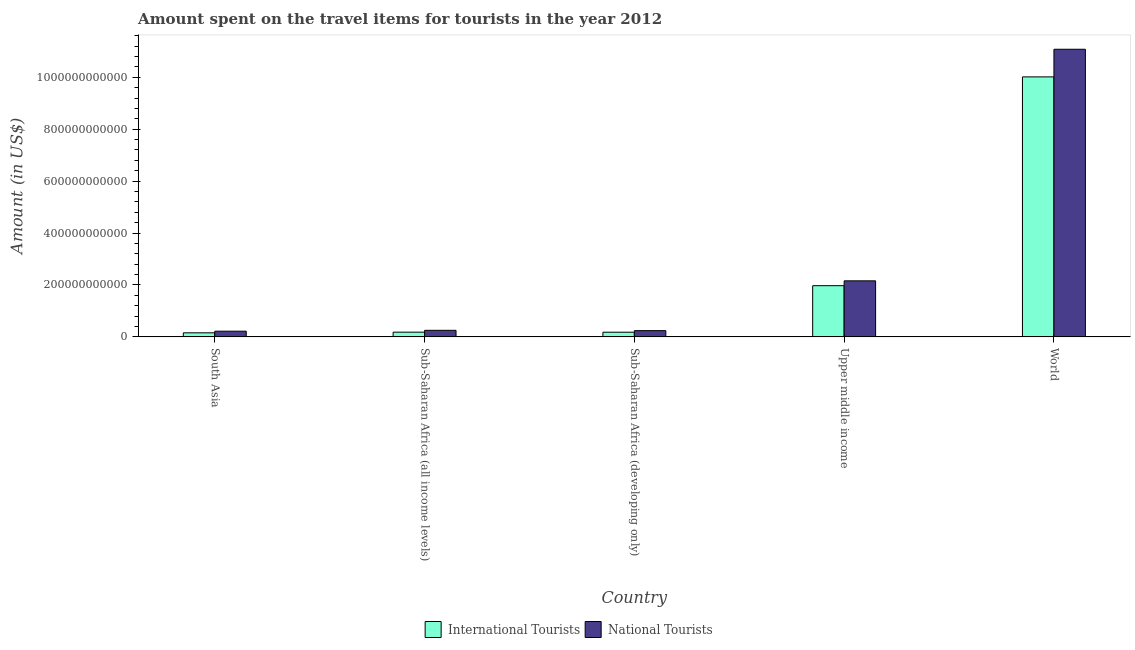How many different coloured bars are there?
Provide a succinct answer. 2. Are the number of bars per tick equal to the number of legend labels?
Keep it short and to the point. Yes. What is the label of the 3rd group of bars from the left?
Your answer should be very brief. Sub-Saharan Africa (developing only). What is the amount spent on travel items of national tourists in Sub-Saharan Africa (developing only)?
Offer a very short reply. 2.40e+1. Across all countries, what is the maximum amount spent on travel items of international tourists?
Your answer should be very brief. 1.00e+12. Across all countries, what is the minimum amount spent on travel items of national tourists?
Your answer should be very brief. 2.19e+1. In which country was the amount spent on travel items of international tourists maximum?
Offer a terse response. World. In which country was the amount spent on travel items of national tourists minimum?
Your response must be concise. South Asia. What is the total amount spent on travel items of national tourists in the graph?
Your answer should be compact. 1.40e+12. What is the difference between the amount spent on travel items of national tourists in South Asia and that in Sub-Saharan Africa (developing only)?
Your response must be concise. -2.14e+09. What is the difference between the amount spent on travel items of international tourists in Sub-Saharan Africa (developing only) and the amount spent on travel items of national tourists in World?
Make the answer very short. -1.09e+12. What is the average amount spent on travel items of national tourists per country?
Provide a short and direct response. 2.79e+11. What is the difference between the amount spent on travel items of national tourists and amount spent on travel items of international tourists in Sub-Saharan Africa (all income levels)?
Your response must be concise. 7.15e+09. What is the ratio of the amount spent on travel items of international tourists in Sub-Saharan Africa (all income levels) to that in Sub-Saharan Africa (developing only)?
Provide a succinct answer. 1.01. Is the amount spent on travel items of national tourists in South Asia less than that in Sub-Saharan Africa (developing only)?
Offer a terse response. Yes. Is the difference between the amount spent on travel items of national tourists in Sub-Saharan Africa (all income levels) and World greater than the difference between the amount spent on travel items of international tourists in Sub-Saharan Africa (all income levels) and World?
Make the answer very short. No. What is the difference between the highest and the second highest amount spent on travel items of international tourists?
Provide a succinct answer. 8.04e+11. What is the difference between the highest and the lowest amount spent on travel items of national tourists?
Offer a terse response. 1.09e+12. Is the sum of the amount spent on travel items of international tourists in Sub-Saharan Africa (developing only) and Upper middle income greater than the maximum amount spent on travel items of national tourists across all countries?
Make the answer very short. No. What does the 1st bar from the left in Sub-Saharan Africa (developing only) represents?
Keep it short and to the point. International Tourists. What does the 2nd bar from the right in World represents?
Provide a succinct answer. International Tourists. What is the difference between two consecutive major ticks on the Y-axis?
Keep it short and to the point. 2.00e+11. Are the values on the major ticks of Y-axis written in scientific E-notation?
Give a very brief answer. No. How many legend labels are there?
Offer a terse response. 2. How are the legend labels stacked?
Give a very brief answer. Horizontal. What is the title of the graph?
Your answer should be compact. Amount spent on the travel items for tourists in the year 2012. Does "Nitrous oxide emissions" appear as one of the legend labels in the graph?
Give a very brief answer. No. What is the Amount (in US$) in International Tourists in South Asia?
Keep it short and to the point. 1.56e+1. What is the Amount (in US$) of National Tourists in South Asia?
Offer a terse response. 2.19e+1. What is the Amount (in US$) in International Tourists in Sub-Saharan Africa (all income levels)?
Your response must be concise. 1.81e+1. What is the Amount (in US$) in National Tourists in Sub-Saharan Africa (all income levels)?
Your answer should be compact. 2.53e+1. What is the Amount (in US$) in International Tourists in Sub-Saharan Africa (developing only)?
Provide a short and direct response. 1.79e+1. What is the Amount (in US$) of National Tourists in Sub-Saharan Africa (developing only)?
Your answer should be compact. 2.40e+1. What is the Amount (in US$) of International Tourists in Upper middle income?
Your response must be concise. 1.97e+11. What is the Amount (in US$) in National Tourists in Upper middle income?
Your answer should be very brief. 2.16e+11. What is the Amount (in US$) in International Tourists in World?
Give a very brief answer. 1.00e+12. What is the Amount (in US$) of National Tourists in World?
Your response must be concise. 1.11e+12. Across all countries, what is the maximum Amount (in US$) of International Tourists?
Offer a terse response. 1.00e+12. Across all countries, what is the maximum Amount (in US$) of National Tourists?
Your answer should be very brief. 1.11e+12. Across all countries, what is the minimum Amount (in US$) in International Tourists?
Keep it short and to the point. 1.56e+1. Across all countries, what is the minimum Amount (in US$) in National Tourists?
Your response must be concise. 2.19e+1. What is the total Amount (in US$) of International Tourists in the graph?
Your response must be concise. 1.25e+12. What is the total Amount (in US$) in National Tourists in the graph?
Ensure brevity in your answer.  1.40e+12. What is the difference between the Amount (in US$) in International Tourists in South Asia and that in Sub-Saharan Africa (all income levels)?
Offer a terse response. -2.49e+09. What is the difference between the Amount (in US$) in National Tourists in South Asia and that in Sub-Saharan Africa (all income levels)?
Offer a very short reply. -3.35e+09. What is the difference between the Amount (in US$) of International Tourists in South Asia and that in Sub-Saharan Africa (developing only)?
Keep it short and to the point. -2.32e+09. What is the difference between the Amount (in US$) in National Tourists in South Asia and that in Sub-Saharan Africa (developing only)?
Your answer should be very brief. -2.14e+09. What is the difference between the Amount (in US$) in International Tourists in South Asia and that in Upper middle income?
Offer a very short reply. -1.82e+11. What is the difference between the Amount (in US$) in National Tourists in South Asia and that in Upper middle income?
Your response must be concise. -1.94e+11. What is the difference between the Amount (in US$) in International Tourists in South Asia and that in World?
Offer a very short reply. -9.86e+11. What is the difference between the Amount (in US$) in National Tourists in South Asia and that in World?
Ensure brevity in your answer.  -1.09e+12. What is the difference between the Amount (in US$) in International Tourists in Sub-Saharan Africa (all income levels) and that in Sub-Saharan Africa (developing only)?
Ensure brevity in your answer.  1.68e+08. What is the difference between the Amount (in US$) of National Tourists in Sub-Saharan Africa (all income levels) and that in Sub-Saharan Africa (developing only)?
Provide a short and direct response. 1.21e+09. What is the difference between the Amount (in US$) in International Tourists in Sub-Saharan Africa (all income levels) and that in Upper middle income?
Give a very brief answer. -1.79e+11. What is the difference between the Amount (in US$) in National Tourists in Sub-Saharan Africa (all income levels) and that in Upper middle income?
Make the answer very short. -1.91e+11. What is the difference between the Amount (in US$) of International Tourists in Sub-Saharan Africa (all income levels) and that in World?
Provide a succinct answer. -9.84e+11. What is the difference between the Amount (in US$) of National Tourists in Sub-Saharan Africa (all income levels) and that in World?
Offer a terse response. -1.08e+12. What is the difference between the Amount (in US$) of International Tourists in Sub-Saharan Africa (developing only) and that in Upper middle income?
Offer a terse response. -1.79e+11. What is the difference between the Amount (in US$) of National Tourists in Sub-Saharan Africa (developing only) and that in Upper middle income?
Give a very brief answer. -1.92e+11. What is the difference between the Amount (in US$) in International Tourists in Sub-Saharan Africa (developing only) and that in World?
Ensure brevity in your answer.  -9.84e+11. What is the difference between the Amount (in US$) in National Tourists in Sub-Saharan Africa (developing only) and that in World?
Your response must be concise. -1.08e+12. What is the difference between the Amount (in US$) of International Tourists in Upper middle income and that in World?
Provide a short and direct response. -8.04e+11. What is the difference between the Amount (in US$) in National Tourists in Upper middle income and that in World?
Your response must be concise. -8.92e+11. What is the difference between the Amount (in US$) in International Tourists in South Asia and the Amount (in US$) in National Tourists in Sub-Saharan Africa (all income levels)?
Offer a terse response. -9.64e+09. What is the difference between the Amount (in US$) of International Tourists in South Asia and the Amount (in US$) of National Tourists in Sub-Saharan Africa (developing only)?
Make the answer very short. -8.43e+09. What is the difference between the Amount (in US$) in International Tourists in South Asia and the Amount (in US$) in National Tourists in Upper middle income?
Ensure brevity in your answer.  -2.00e+11. What is the difference between the Amount (in US$) of International Tourists in South Asia and the Amount (in US$) of National Tourists in World?
Your response must be concise. -1.09e+12. What is the difference between the Amount (in US$) of International Tourists in Sub-Saharan Africa (all income levels) and the Amount (in US$) of National Tourists in Sub-Saharan Africa (developing only)?
Your answer should be very brief. -5.93e+09. What is the difference between the Amount (in US$) in International Tourists in Sub-Saharan Africa (all income levels) and the Amount (in US$) in National Tourists in Upper middle income?
Ensure brevity in your answer.  -1.98e+11. What is the difference between the Amount (in US$) of International Tourists in Sub-Saharan Africa (all income levels) and the Amount (in US$) of National Tourists in World?
Your answer should be compact. -1.09e+12. What is the difference between the Amount (in US$) of International Tourists in Sub-Saharan Africa (developing only) and the Amount (in US$) of National Tourists in Upper middle income?
Your answer should be very brief. -1.98e+11. What is the difference between the Amount (in US$) of International Tourists in Sub-Saharan Africa (developing only) and the Amount (in US$) of National Tourists in World?
Make the answer very short. -1.09e+12. What is the difference between the Amount (in US$) in International Tourists in Upper middle income and the Amount (in US$) in National Tourists in World?
Give a very brief answer. -9.11e+11. What is the average Amount (in US$) in International Tourists per country?
Give a very brief answer. 2.50e+11. What is the average Amount (in US$) of National Tourists per country?
Your response must be concise. 2.79e+11. What is the difference between the Amount (in US$) in International Tourists and Amount (in US$) in National Tourists in South Asia?
Provide a short and direct response. -6.29e+09. What is the difference between the Amount (in US$) of International Tourists and Amount (in US$) of National Tourists in Sub-Saharan Africa (all income levels)?
Keep it short and to the point. -7.15e+09. What is the difference between the Amount (in US$) in International Tourists and Amount (in US$) in National Tourists in Sub-Saharan Africa (developing only)?
Give a very brief answer. -6.10e+09. What is the difference between the Amount (in US$) in International Tourists and Amount (in US$) in National Tourists in Upper middle income?
Give a very brief answer. -1.86e+1. What is the difference between the Amount (in US$) of International Tourists and Amount (in US$) of National Tourists in World?
Make the answer very short. -1.06e+11. What is the ratio of the Amount (in US$) of International Tourists in South Asia to that in Sub-Saharan Africa (all income levels)?
Provide a succinct answer. 0.86. What is the ratio of the Amount (in US$) of National Tourists in South Asia to that in Sub-Saharan Africa (all income levels)?
Offer a terse response. 0.87. What is the ratio of the Amount (in US$) of International Tourists in South Asia to that in Sub-Saharan Africa (developing only)?
Provide a succinct answer. 0.87. What is the ratio of the Amount (in US$) in National Tourists in South Asia to that in Sub-Saharan Africa (developing only)?
Offer a terse response. 0.91. What is the ratio of the Amount (in US$) in International Tourists in South Asia to that in Upper middle income?
Offer a terse response. 0.08. What is the ratio of the Amount (in US$) of National Tourists in South Asia to that in Upper middle income?
Give a very brief answer. 0.1. What is the ratio of the Amount (in US$) of International Tourists in South Asia to that in World?
Offer a very short reply. 0.02. What is the ratio of the Amount (in US$) in National Tourists in South Asia to that in World?
Ensure brevity in your answer.  0.02. What is the ratio of the Amount (in US$) in International Tourists in Sub-Saharan Africa (all income levels) to that in Sub-Saharan Africa (developing only)?
Your answer should be compact. 1.01. What is the ratio of the Amount (in US$) of National Tourists in Sub-Saharan Africa (all income levels) to that in Sub-Saharan Africa (developing only)?
Your answer should be very brief. 1.05. What is the ratio of the Amount (in US$) in International Tourists in Sub-Saharan Africa (all income levels) to that in Upper middle income?
Provide a succinct answer. 0.09. What is the ratio of the Amount (in US$) in National Tourists in Sub-Saharan Africa (all income levels) to that in Upper middle income?
Your response must be concise. 0.12. What is the ratio of the Amount (in US$) of International Tourists in Sub-Saharan Africa (all income levels) to that in World?
Provide a succinct answer. 0.02. What is the ratio of the Amount (in US$) in National Tourists in Sub-Saharan Africa (all income levels) to that in World?
Give a very brief answer. 0.02. What is the ratio of the Amount (in US$) in International Tourists in Sub-Saharan Africa (developing only) to that in Upper middle income?
Provide a succinct answer. 0.09. What is the ratio of the Amount (in US$) of National Tourists in Sub-Saharan Africa (developing only) to that in Upper middle income?
Your answer should be compact. 0.11. What is the ratio of the Amount (in US$) in International Tourists in Sub-Saharan Africa (developing only) to that in World?
Your answer should be compact. 0.02. What is the ratio of the Amount (in US$) in National Tourists in Sub-Saharan Africa (developing only) to that in World?
Your response must be concise. 0.02. What is the ratio of the Amount (in US$) in International Tourists in Upper middle income to that in World?
Offer a very short reply. 0.2. What is the ratio of the Amount (in US$) of National Tourists in Upper middle income to that in World?
Offer a very short reply. 0.19. What is the difference between the highest and the second highest Amount (in US$) in International Tourists?
Your response must be concise. 8.04e+11. What is the difference between the highest and the second highest Amount (in US$) in National Tourists?
Your answer should be very brief. 8.92e+11. What is the difference between the highest and the lowest Amount (in US$) of International Tourists?
Provide a succinct answer. 9.86e+11. What is the difference between the highest and the lowest Amount (in US$) of National Tourists?
Your answer should be very brief. 1.09e+12. 